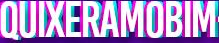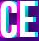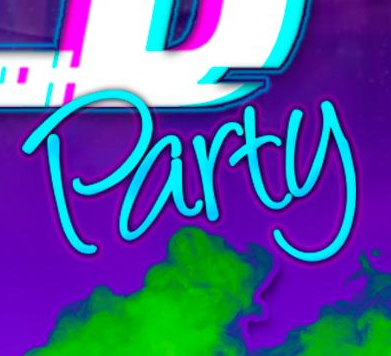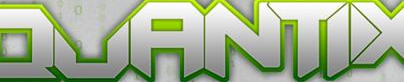Identify the words shown in these images in order, separated by a semicolon. QUIXERAMOBIM; CE; Party; QUANTIX 